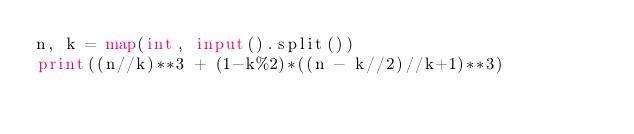Convert code to text. <code><loc_0><loc_0><loc_500><loc_500><_Python_>n, k = map(int, input().split())
print((n//k)**3 + (1-k%2)*((n - k//2)//k+1)**3)</code> 